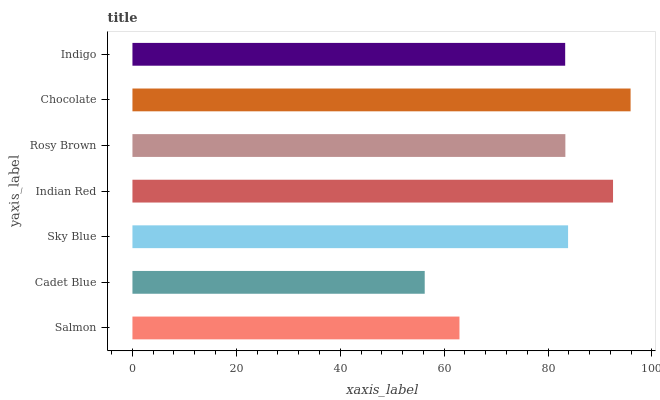Is Cadet Blue the minimum?
Answer yes or no. Yes. Is Chocolate the maximum?
Answer yes or no. Yes. Is Sky Blue the minimum?
Answer yes or no. No. Is Sky Blue the maximum?
Answer yes or no. No. Is Sky Blue greater than Cadet Blue?
Answer yes or no. Yes. Is Cadet Blue less than Sky Blue?
Answer yes or no. Yes. Is Cadet Blue greater than Sky Blue?
Answer yes or no. No. Is Sky Blue less than Cadet Blue?
Answer yes or no. No. Is Rosy Brown the high median?
Answer yes or no. Yes. Is Rosy Brown the low median?
Answer yes or no. Yes. Is Sky Blue the high median?
Answer yes or no. No. Is Chocolate the low median?
Answer yes or no. No. 